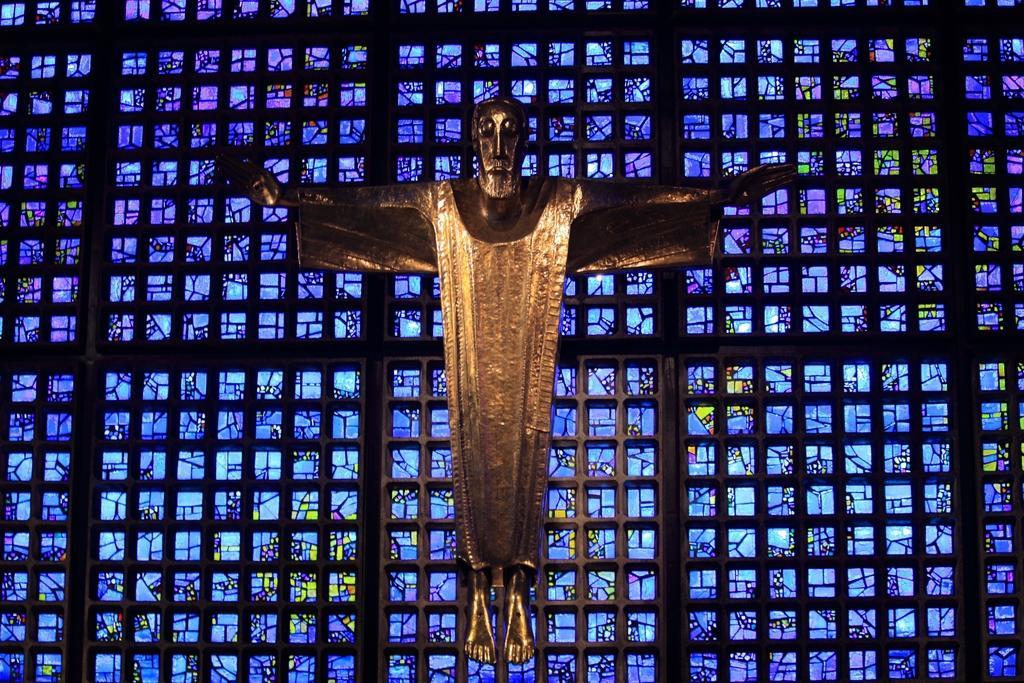In one or two sentences, can you explain what this image depicts? In this image we can see a statue of a man which is in gold color and in the background of the image there is sheet which is of blue and black color. 